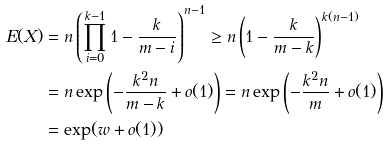<formula> <loc_0><loc_0><loc_500><loc_500>E ( X ) & = n \left ( \prod _ { i = 0 } ^ { k - 1 } 1 - \frac { k } { m - i } \right ) ^ { n - 1 } \geq n \left ( 1 - \frac { k } { m - k } \right ) ^ { k ( n - 1 ) } \\ & = n \exp \left ( - \frac { k ^ { 2 } n } { m - k } + o ( 1 ) \right ) = n \exp \left ( - \frac { k ^ { 2 } n } { m } + o ( 1 ) \right ) \\ & = \exp ( w + o ( 1 ) )</formula> 